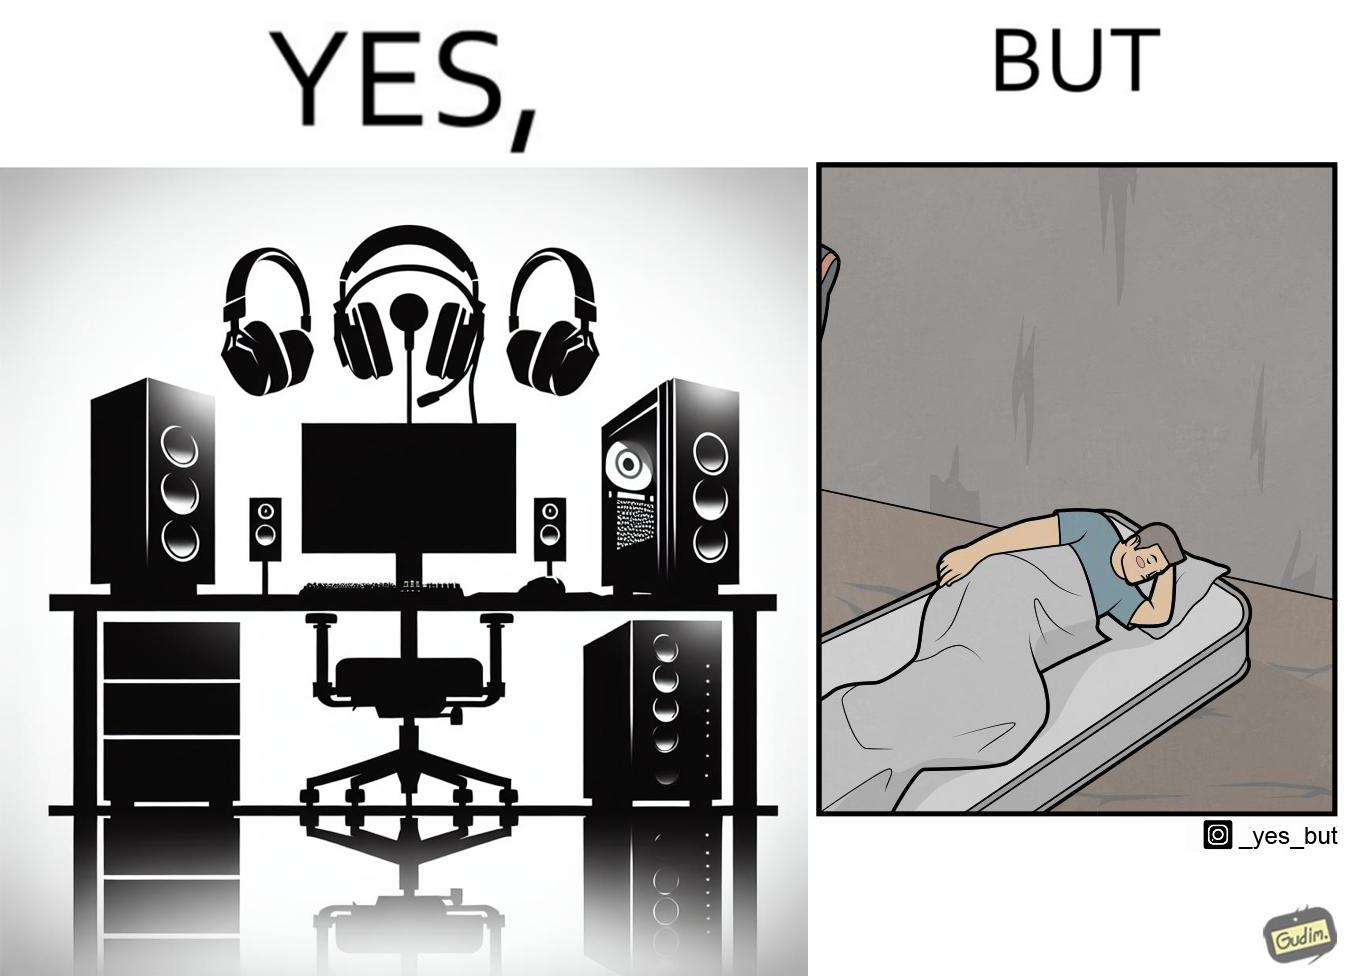Is this a satirical image? Yes, this image is satirical. 